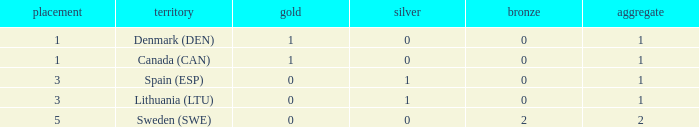What is the number of gold medals for Lithuania (ltu), when the total is more than 1? None. 